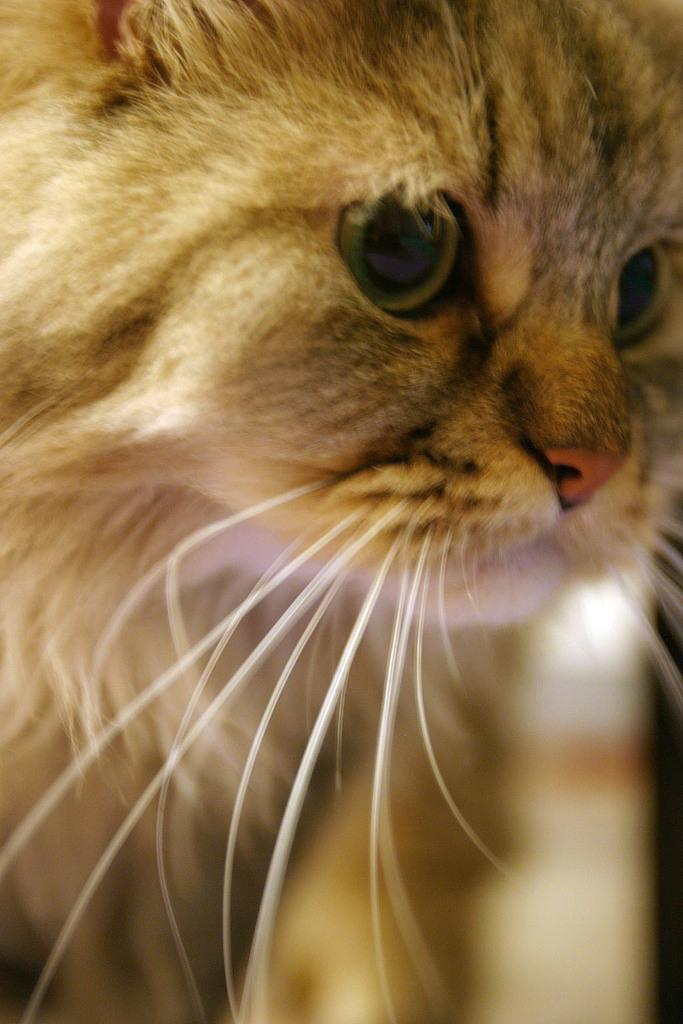What type of animal is present in the image? There is a cat in the image. What specific feature of the cat can be seen in the image? The cat's whiskers are visible in the image. What type of grape can be seen growing on the cat's wing in the image? There is no grape or wing present in the image; it features a cat with visible whiskers. 